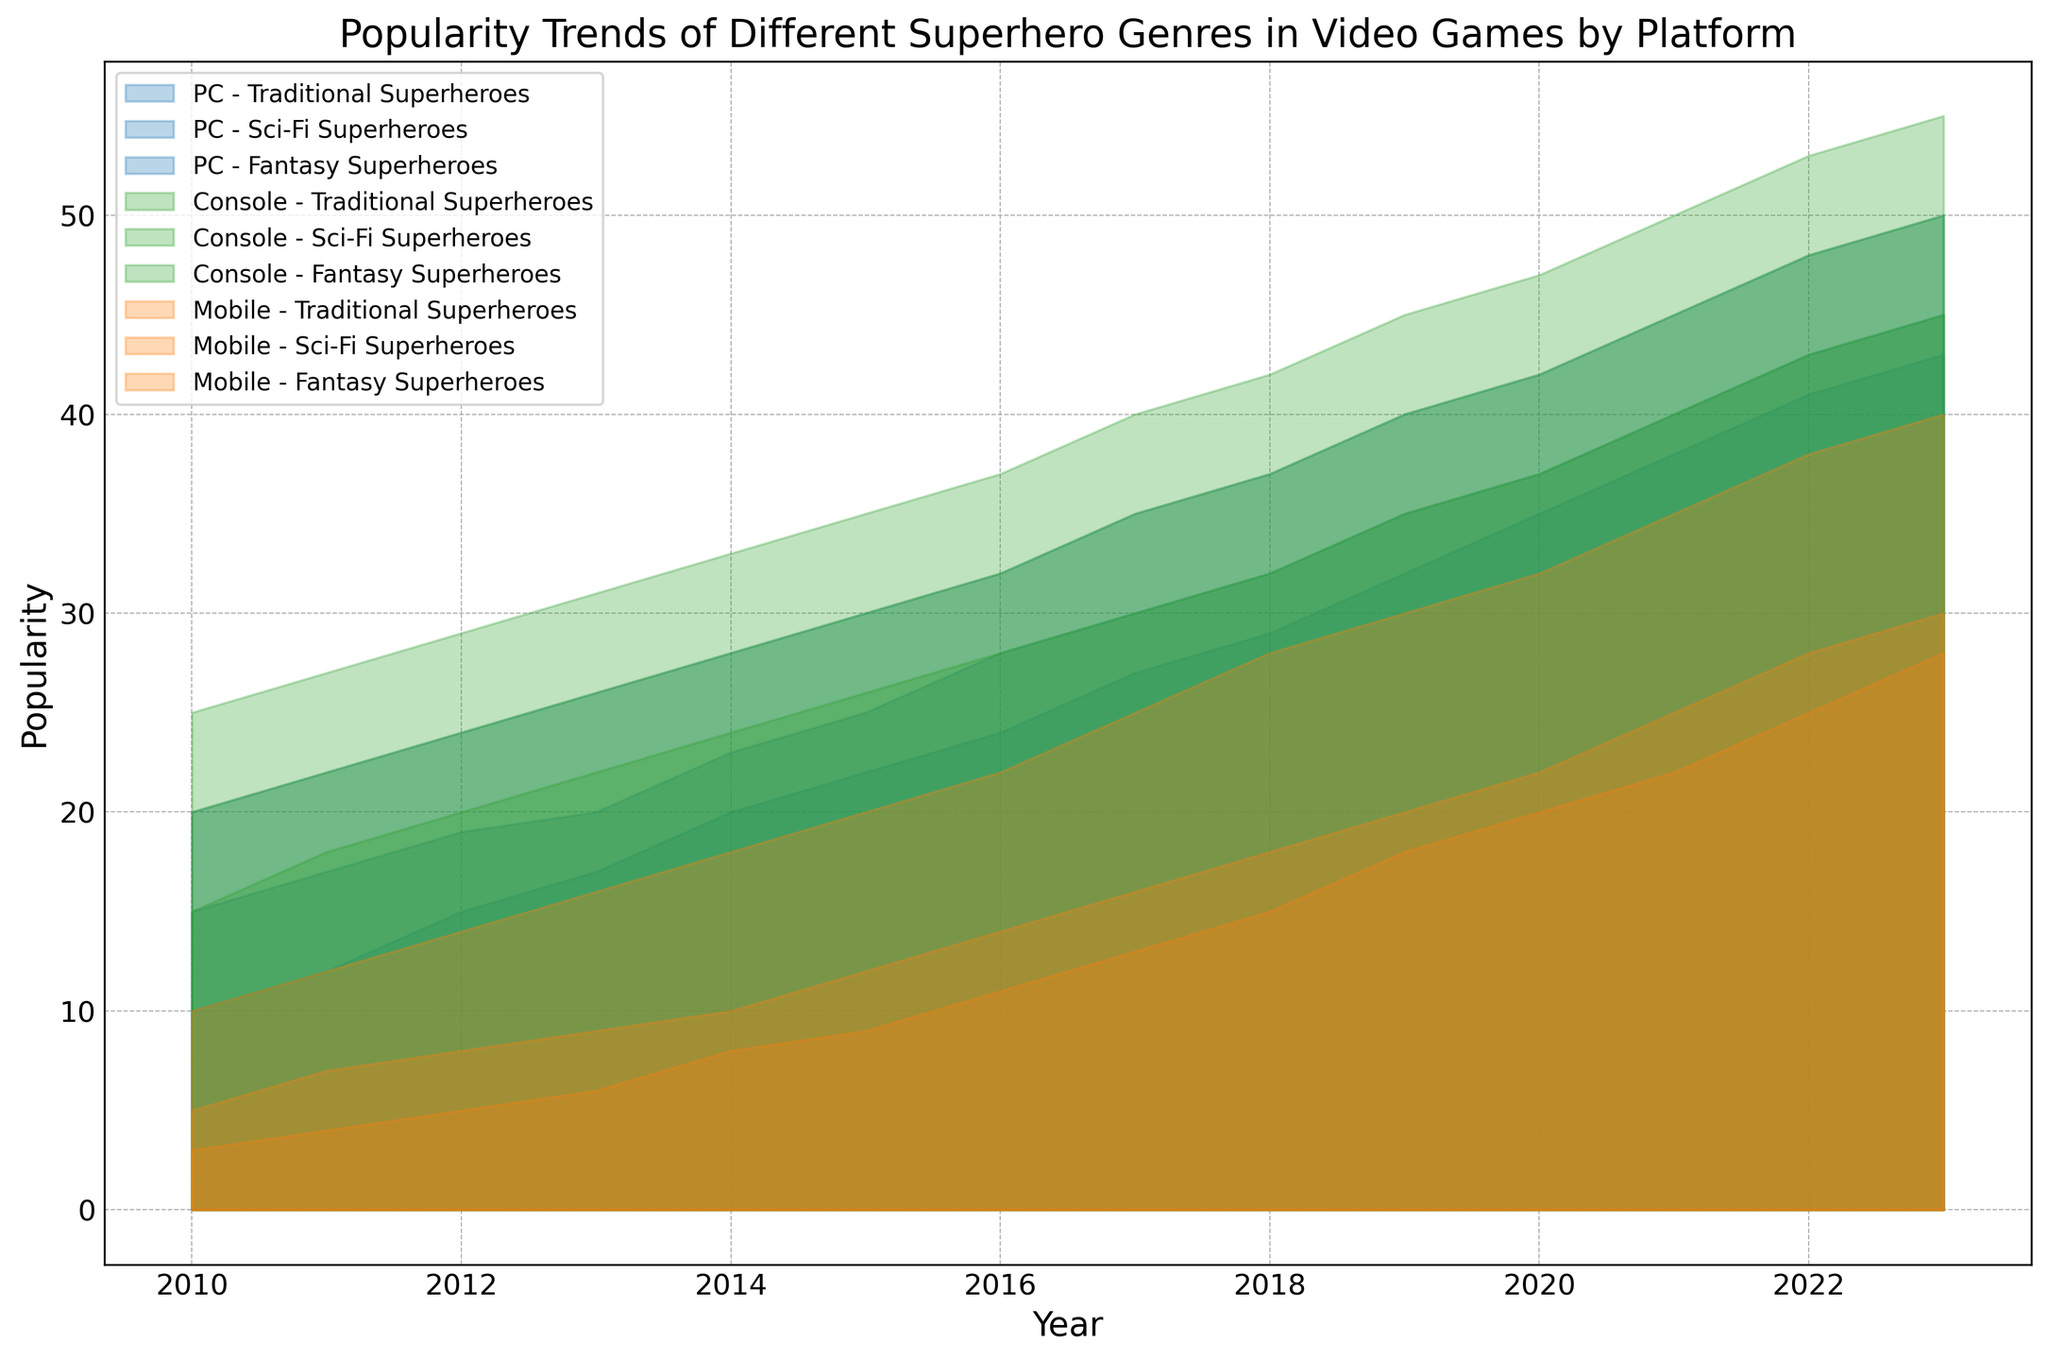What's the general trend of popularity for Traditional Superheroes on PC from 2010 to 2023? The area chart shows a positive upward trend for Traditional Superheroes on PC. Observing the plot, the popularity values for PC in 2010 start at 20 and steadily climb each year, reaching a peak of 50 by 2023.
Answer: Increasing Which platform had the greatest popularity for Fantasy Superheroes in 2023? For 2023, the area chart indicates that the Console platform has the highest area representation for Fantasy Superheroes when compared to PC and Mobile platforms. The values in the dataset show the Console at 45, PC at 43, and Mobile at 28 in 2023.
Answer: Console How does the popularity of Sci-Fi Superheroes on Mobile in 2010 compare to its popularity on Console in the same year? From the chart, you can observe that the popularity of Sci-Fi Superheroes on Mobile in 2010 is represented by a smaller area compared to the Console. The dataset supports this with values of 5 for Mobile and 20 for Console in 2010.
Answer: Lower What is the total popularity of all superhero genres on all platforms combined in 2015? Summing up the values from the dataset for 2015: Traditional Superheroes (PC: 30, Console: 35, Mobile: 20), Sci-Fi Superheroes (PC: 25, Console: 30, Mobile: 12), Fantasy Superheroes (PC: 22, Console: 26, Mobile: 9). (30+35+20) + (25+30+12) + (22+26+9) = 167.
Answer: 167 Which superhero genre shows a consistent increase in popularity across all platforms from 2010 to 2023? Analyzing the trends from 2010 to 2023 for each genre by platform, Traditional Superheroes display a clear and steady increase for PC, Console, and Mobile platforms, as evident in the area chart and supported by increasing values in the dataset.
Answer: Traditional Superheroes Between PC and Mobile platforms, which showed a larger increase in popularity for Fantasy Superheroes from 2010 to 2023? The increase for Fantasy Superheroes from 2010 to 2023 for PC is (43 - 10) = 33, and for Mobile is (28 - 3) = 25. Therefore, the PC platform shows a larger increase.
Answer: PC What was the difference in popularity of Sci-Fi Superheroes between PC and Console in 2020? The dataset shows that in 2020 the popularity values for Sci-Fi Superheroes are 37 for PC and 42 for Console. The difference is 42 - 37 = 5.
Answer: 5 In which year did the Mobile platform see the greatest increase in popularity for Traditional Superheroes compared to the previous year? Observing the yearly increments for Mobile in Traditional Superheroes: from 2010 to 2011 (+2), 2011 to 2012 (+2), 2012 to 2013 (+2), 2013 to 2014 (+2), and so on, the largest increment  happens from 2017 to 2018 (+3).
Answer: 2018 By how much did the popularity of Sci-Fi Superheroes on Consoles increase from 2010 to 2023? The increase for Sci-Fi Superheroes on Console from 2010 (20) to 2023 (50) is 50 - 20 = 30.
Answer: 30 